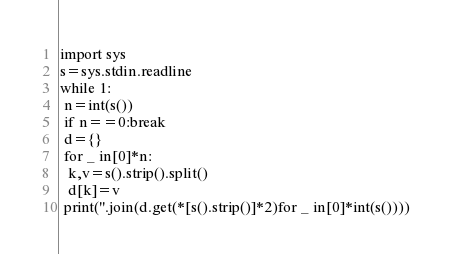Convert code to text. <code><loc_0><loc_0><loc_500><loc_500><_Python_>import sys
s=sys.stdin.readline
while 1:
 n=int(s())
 if n==0:break
 d={}
 for _ in[0]*n:
  k,v=s().strip().split()
  d[k]=v
 print(''.join(d.get(*[s().strip()]*2)for _ in[0]*int(s())))
</code> 